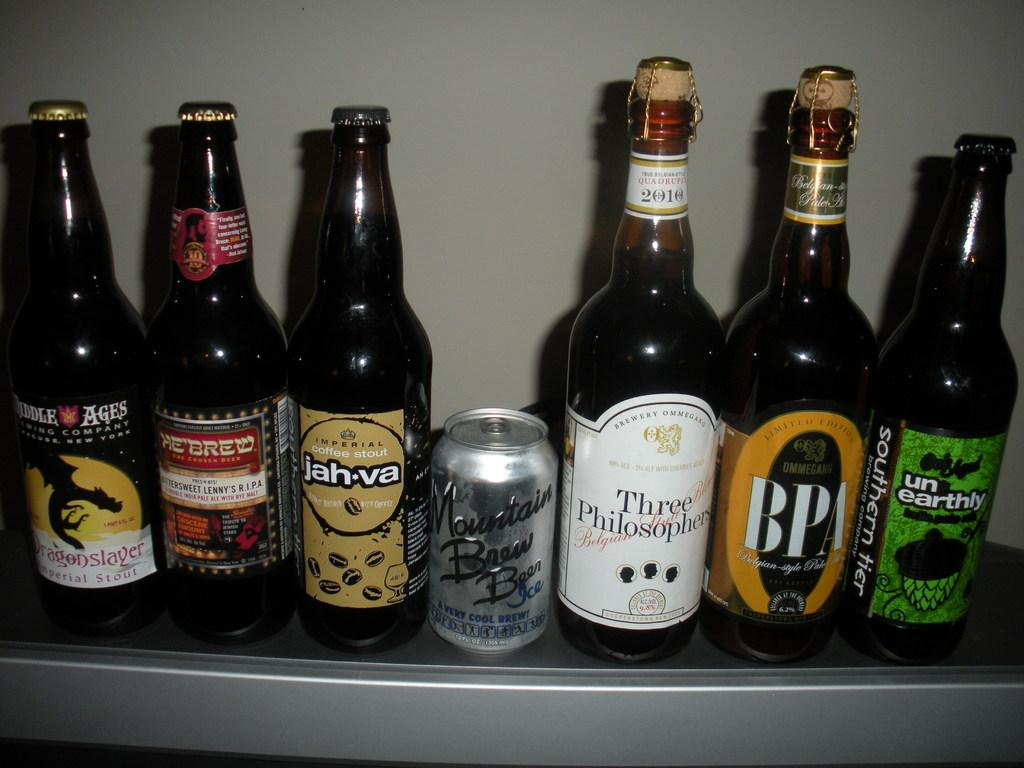<image>
Write a terse but informative summary of the picture. A can of Mountain Brew beer is on a shelf in between six bottles of beer. 